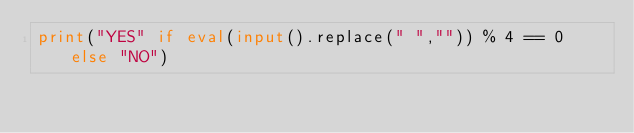Convert code to text. <code><loc_0><loc_0><loc_500><loc_500><_Python_>print("YES" if eval(input().replace(" ","")) % 4 == 0 else "NO")</code> 